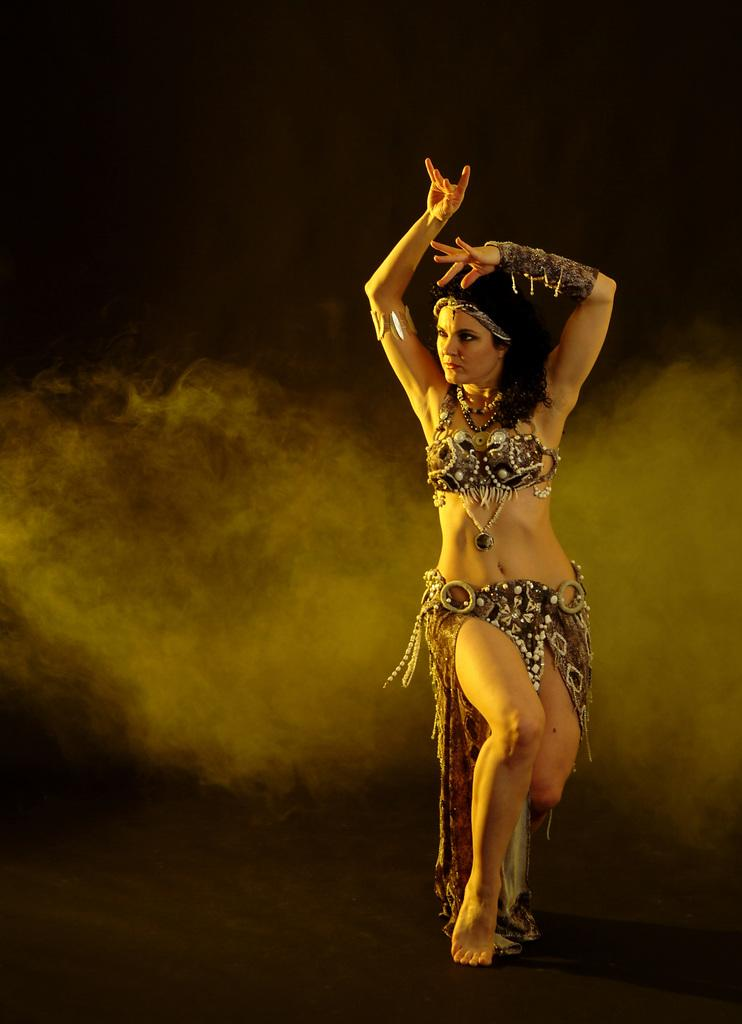Who is the main subject in the image? There is a woman in the image. What is the woman doing in the image? The woman is dancing on the floor. How would you describe the background of the image? The background of the image is dark. What else can be seen in the image besides the woman? There is smoke visible in the image. Is there a desk present in the image? No, there is no desk visible in the image. Does the existence of the woman in the image prove the existence of a rock? No, the existence of the woman in the image does not prove the existence of a rock, as there is no mention of a rock in the provided facts. 